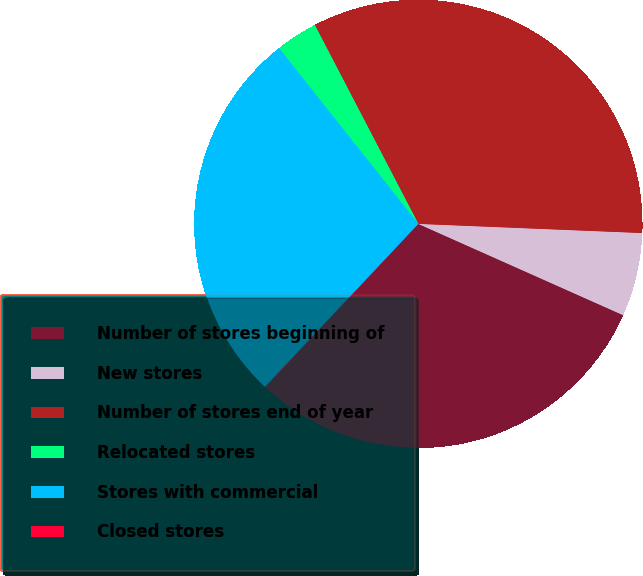<chart> <loc_0><loc_0><loc_500><loc_500><pie_chart><fcel>Number of stores beginning of<fcel>New stores<fcel>Number of stores end of year<fcel>Relocated stores<fcel>Stores with commercial<fcel>Closed stores<nl><fcel>30.3%<fcel>6.02%<fcel>33.29%<fcel>3.03%<fcel>27.32%<fcel>0.04%<nl></chart> 